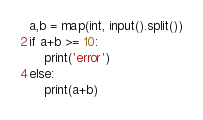Convert code to text. <code><loc_0><loc_0><loc_500><loc_500><_Python_>a,b = map(int, input().split())
if a+b >= 10:
    print('error')
else:
    print(a+b)</code> 